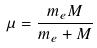<formula> <loc_0><loc_0><loc_500><loc_500>\mu = \frac { m _ { e } M } { m _ { e } + M }</formula> 